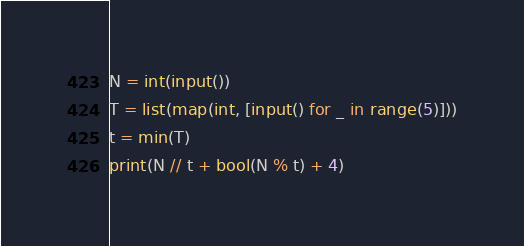<code> <loc_0><loc_0><loc_500><loc_500><_Python_>N = int(input())
T = list(map(int, [input() for _ in range(5)]))
t = min(T)
print(N // t + bool(N % t) + 4)</code> 